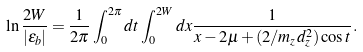Convert formula to latex. <formula><loc_0><loc_0><loc_500><loc_500>\ln \frac { 2 W } { | \varepsilon _ { b } | } = \frac { 1 } { 2 \pi } \int _ { 0 } ^ { 2 \pi } d t \int _ { 0 } ^ { 2 W } d x \frac { 1 } { x - 2 \mu + ( 2 / m _ { z } d _ { z } ^ { 2 } ) \cos t } .</formula> 